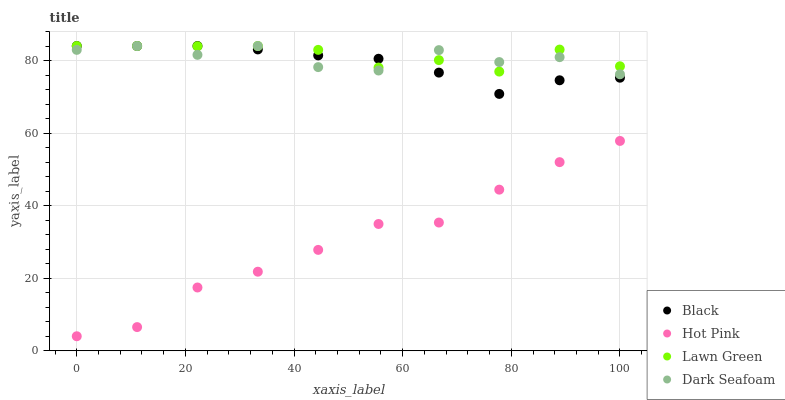Does Hot Pink have the minimum area under the curve?
Answer yes or no. Yes. Does Lawn Green have the maximum area under the curve?
Answer yes or no. Yes. Does Dark Seafoam have the minimum area under the curve?
Answer yes or no. No. Does Dark Seafoam have the maximum area under the curve?
Answer yes or no. No. Is Black the smoothest?
Answer yes or no. Yes. Is Dark Seafoam the roughest?
Answer yes or no. Yes. Is Hot Pink the smoothest?
Answer yes or no. No. Is Hot Pink the roughest?
Answer yes or no. No. Does Hot Pink have the lowest value?
Answer yes or no. Yes. Does Dark Seafoam have the lowest value?
Answer yes or no. No. Does Black have the highest value?
Answer yes or no. Yes. Does Hot Pink have the highest value?
Answer yes or no. No. Is Hot Pink less than Dark Seafoam?
Answer yes or no. Yes. Is Dark Seafoam greater than Hot Pink?
Answer yes or no. Yes. Does Lawn Green intersect Black?
Answer yes or no. Yes. Is Lawn Green less than Black?
Answer yes or no. No. Is Lawn Green greater than Black?
Answer yes or no. No. Does Hot Pink intersect Dark Seafoam?
Answer yes or no. No. 